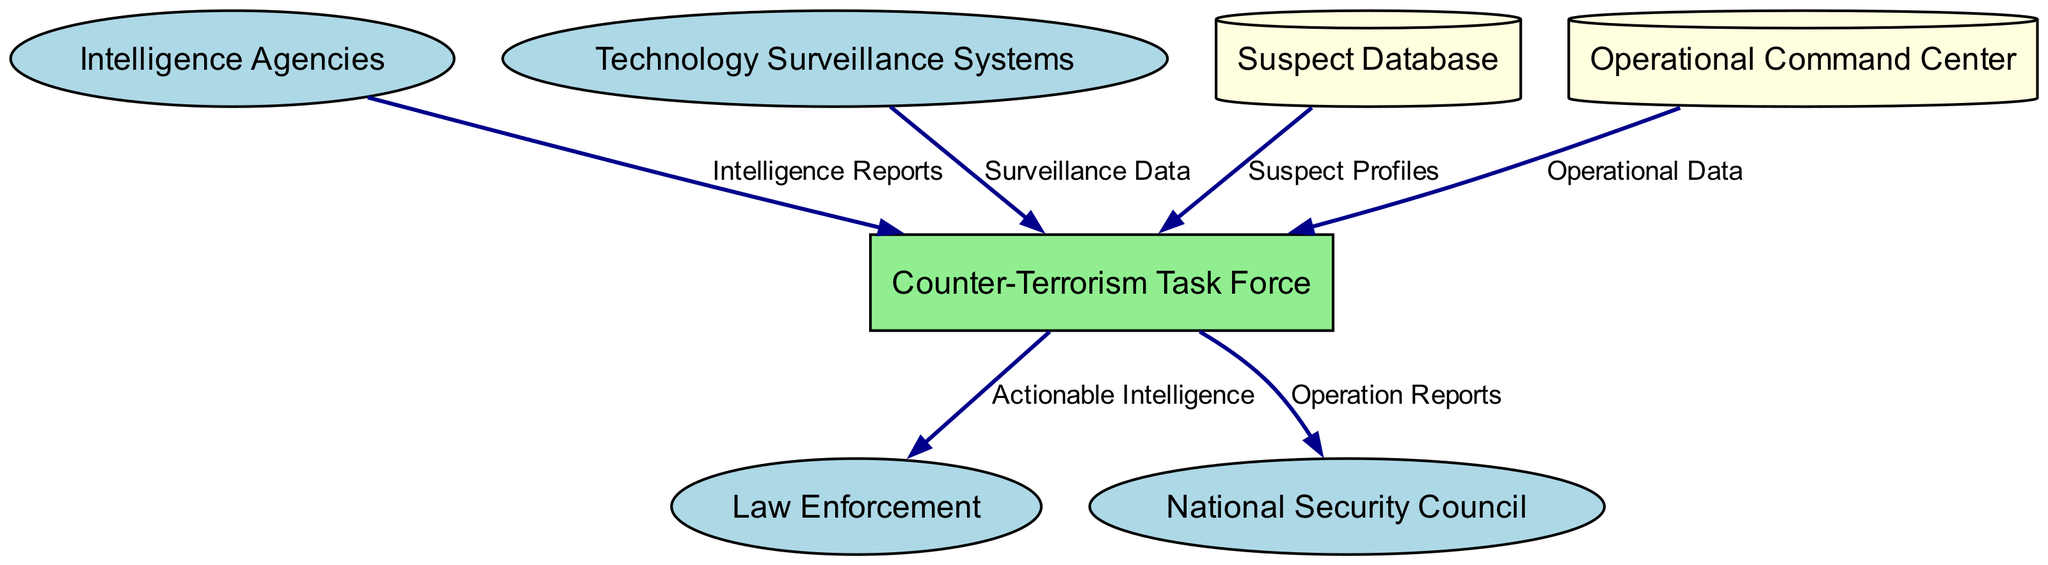What are the entities represented in the diagram? The diagram has six entities identified: Intelligence Agencies, Counter-Terrorism Task Force, Technology Surveillance Systems, Law Enforcement, National Security Council, and Suspect Database. These represent the various actors involved in the counter-terrorism operational workflow.
Answer: Intelligence Agencies, Counter-Terrorism Task Force, Technology Surveillance Systems, Law Enforcement, National Security Council, Suspect Database How many data flows are illustrated in the diagram? By examining the diagram, we can count the arrows connecting the nodes, indicating the data flows. Upon careful inspection, there are six distinct data flows shown, linking the various entities and data stores.
Answer: 6 Which entity provides surveillance data to the Counter-Terrorism Task Force? The arrow showing the flow of "Surveillance Data" points from the "Technology Surveillance Systems" to the "Counter-Terrorism Task Force", indicating that surveillance data is supplied by these systems.
Answer: Technology Surveillance Systems What type of information does the Counter-Terrorism Task Force send to Law Enforcement? The data flow between the "Counter-Terrorism Task Force" and "Law Enforcement" is labeled "Actionable Intelligence", indicating that this specific type of information is sent for immediate operational action.
Answer: Actionable Intelligence What information does the Suspect Database provide to the Counter-Terrorism Task Force? The diagram shows a directed flow of "Suspect Profiles" from the "Suspect Database" to the "Counter-Terrorism Task Force". This indicates that the task force has access to these profiles for investigation purposes.
Answer: Suspect Profiles Which processes does the National Security Council receive from the Counter-Terrorism Task Force? The data flow is labeled "Operation Reports" and connects the "Counter-Terrorism Task Force" to the "National Security Council", demonstrating that this governmental body receives regular updates about ongoing operations.
Answer: Operation Reports How many external entities are depicted in the diagram? The diagram includes four external entities: Intelligence Agencies, Technology Surveillance Systems, Law Enforcement, and National Security Council, which are crucial players in the counter-terrorism operations.
Answer: 4 What is the purpose of the Operational Command Center in the diagram? The "Operational Command Center" is indicated as a data store. The flow of "Operational Data" from this center to the "Counter-Terrorism Task Force" suggests its role in providing live data and updates that assist in monitoring and commanding operations.
Answer: Live data and updates Which entity is responsible for counter-terrorism operations? Based on the diagram, the node labeled "Counter-Terrorism Task Force" is the specialized unit tasked with managing and executing counter-terrorism operations.
Answer: Counter-Terrorism Task Force 